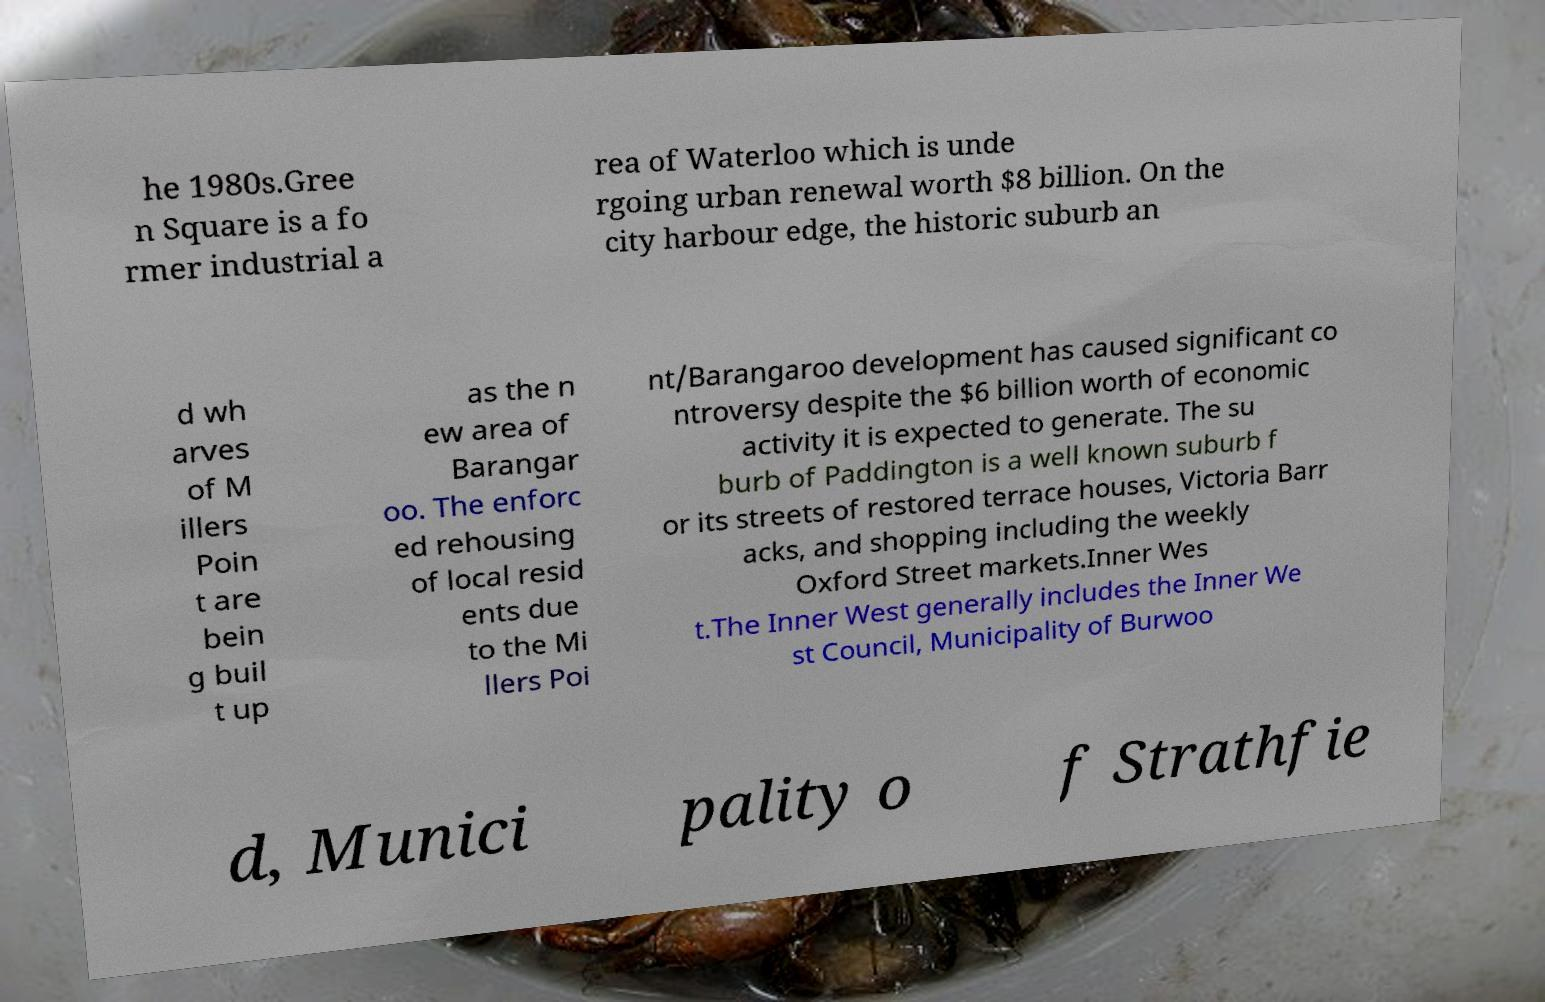Can you accurately transcribe the text from the provided image for me? he 1980s.Gree n Square is a fo rmer industrial a rea of Waterloo which is unde rgoing urban renewal worth $8 billion. On the city harbour edge, the historic suburb an d wh arves of M illers Poin t are bein g buil t up as the n ew area of Barangar oo. The enforc ed rehousing of local resid ents due to the Mi llers Poi nt/Barangaroo development has caused significant co ntroversy despite the $6 billion worth of economic activity it is expected to generate. The su burb of Paddington is a well known suburb f or its streets of restored terrace houses, Victoria Barr acks, and shopping including the weekly Oxford Street markets.Inner Wes t.The Inner West generally includes the Inner We st Council, Municipality of Burwoo d, Munici pality o f Strathfie 